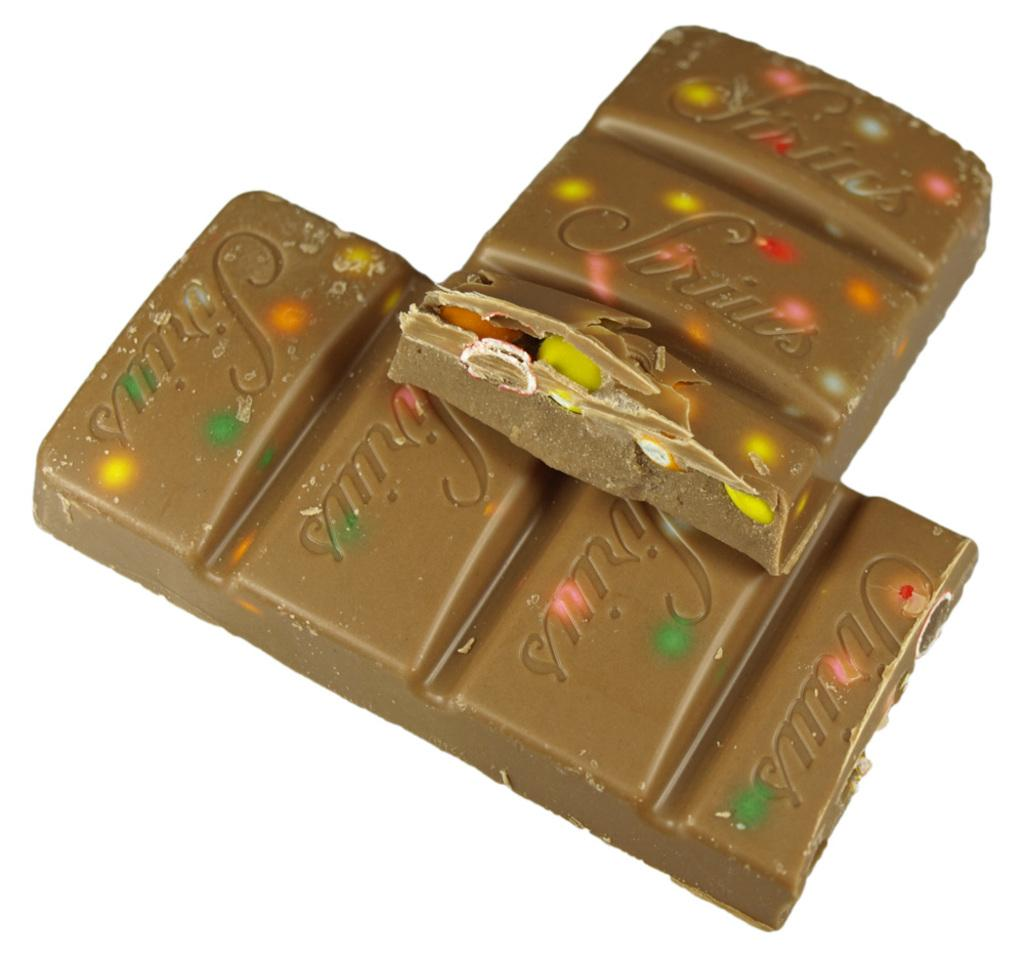What type of food items are present in the image? There are chocolate bars in the image. What can be found on the chocolate bars? The chocolate bars have text on them. Can you describe the appearance of the other food items in the image? There are colorful eatable things in the image. What advice is given on the chocolate bars in the image? There is no advice present on the chocolate bars; they only have text, which may include brand names, ingredients, or other information. 